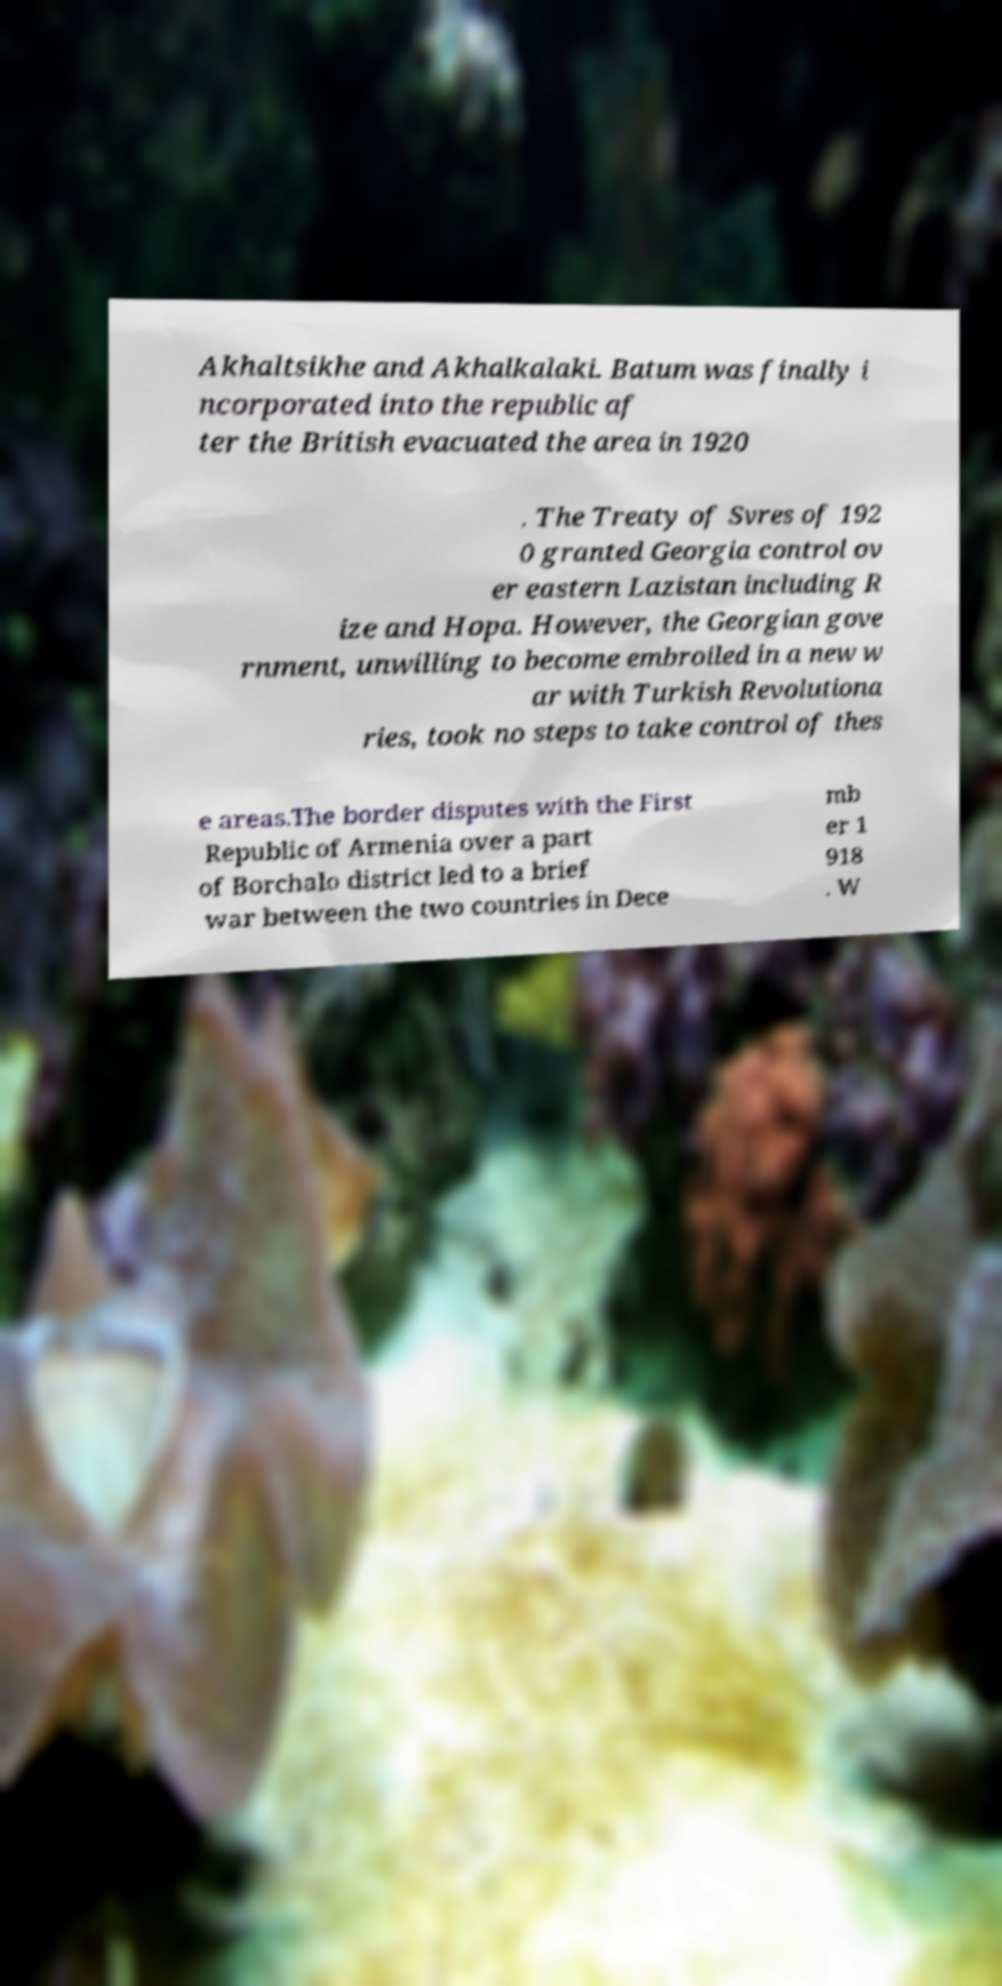What messages or text are displayed in this image? I need them in a readable, typed format. Akhaltsikhe and Akhalkalaki. Batum was finally i ncorporated into the republic af ter the British evacuated the area in 1920 . The Treaty of Svres of 192 0 granted Georgia control ov er eastern Lazistan including R ize and Hopa. However, the Georgian gove rnment, unwilling to become embroiled in a new w ar with Turkish Revolutiona ries, took no steps to take control of thes e areas.The border disputes with the First Republic of Armenia over a part of Borchalo district led to a brief war between the two countries in Dece mb er 1 918 . W 